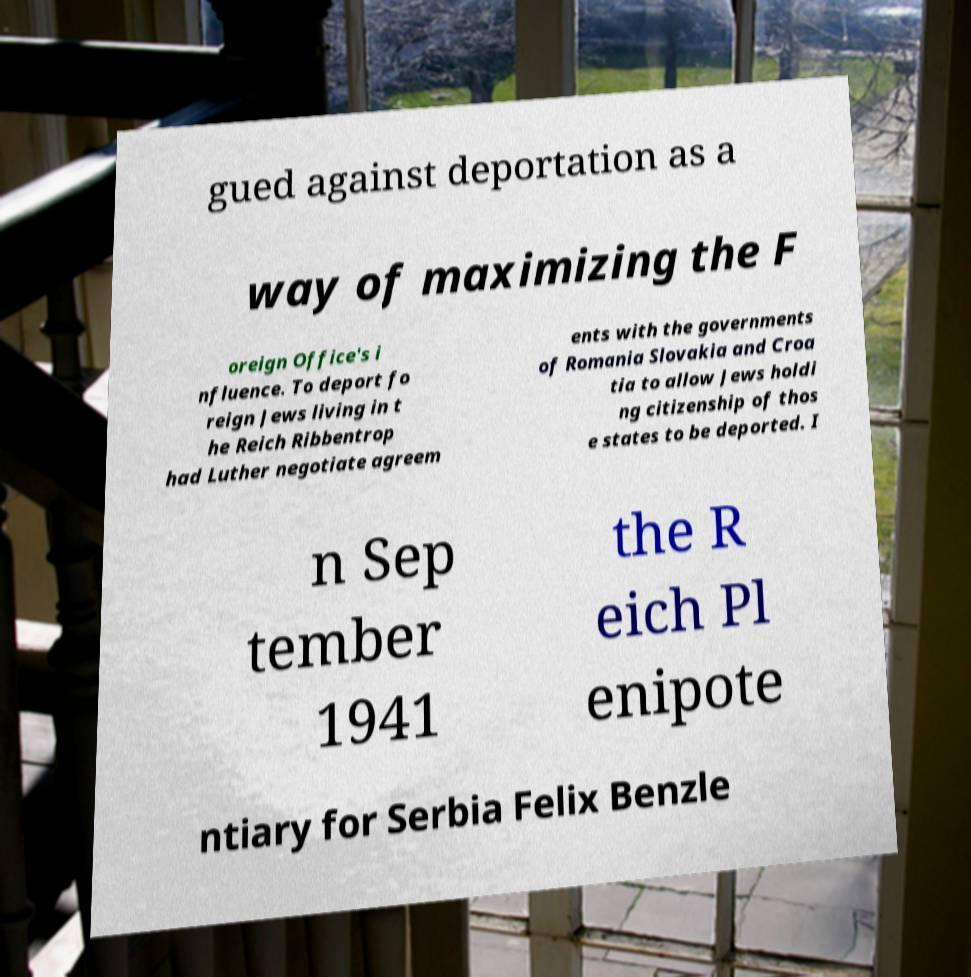Please read and relay the text visible in this image. What does it say? gued against deportation as a way of maximizing the F oreign Office's i nfluence. To deport fo reign Jews living in t he Reich Ribbentrop had Luther negotiate agreem ents with the governments of Romania Slovakia and Croa tia to allow Jews holdi ng citizenship of thos e states to be deported. I n Sep tember 1941 the R eich Pl enipote ntiary for Serbia Felix Benzle 